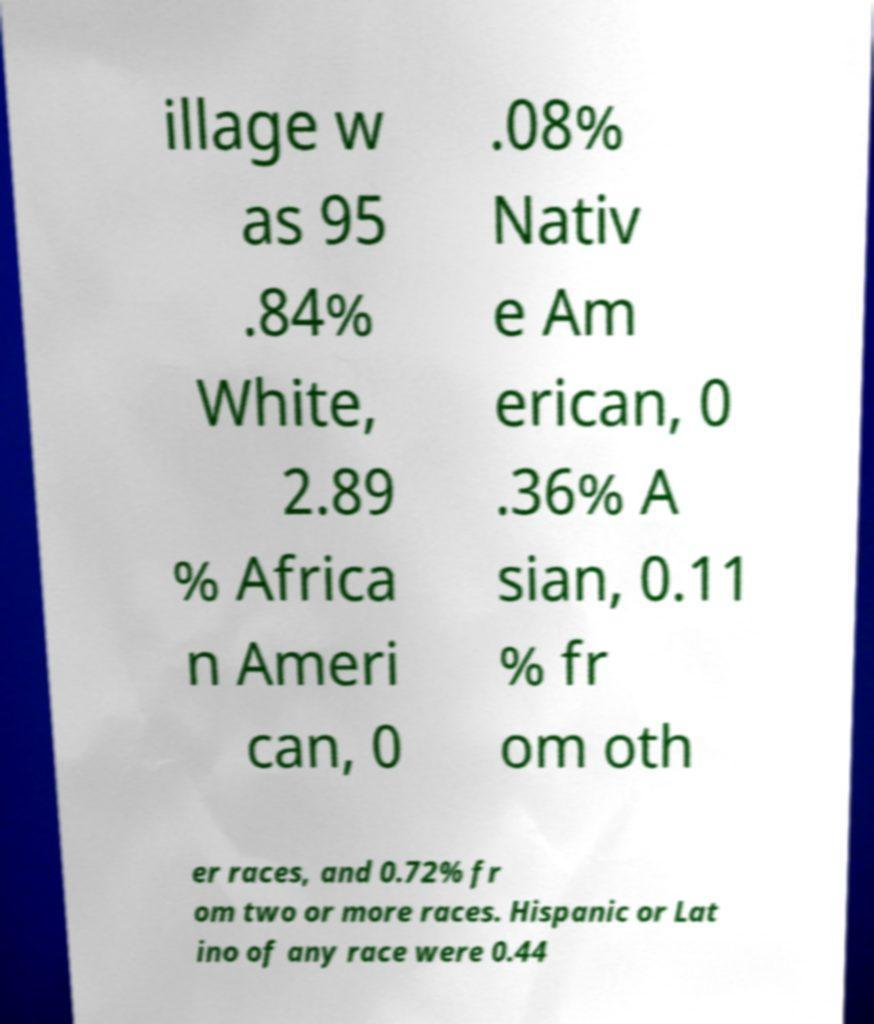There's text embedded in this image that I need extracted. Can you transcribe it verbatim? illage w as 95 .84% White, 2.89 % Africa n Ameri can, 0 .08% Nativ e Am erican, 0 .36% A sian, 0.11 % fr om oth er races, and 0.72% fr om two or more races. Hispanic or Lat ino of any race were 0.44 